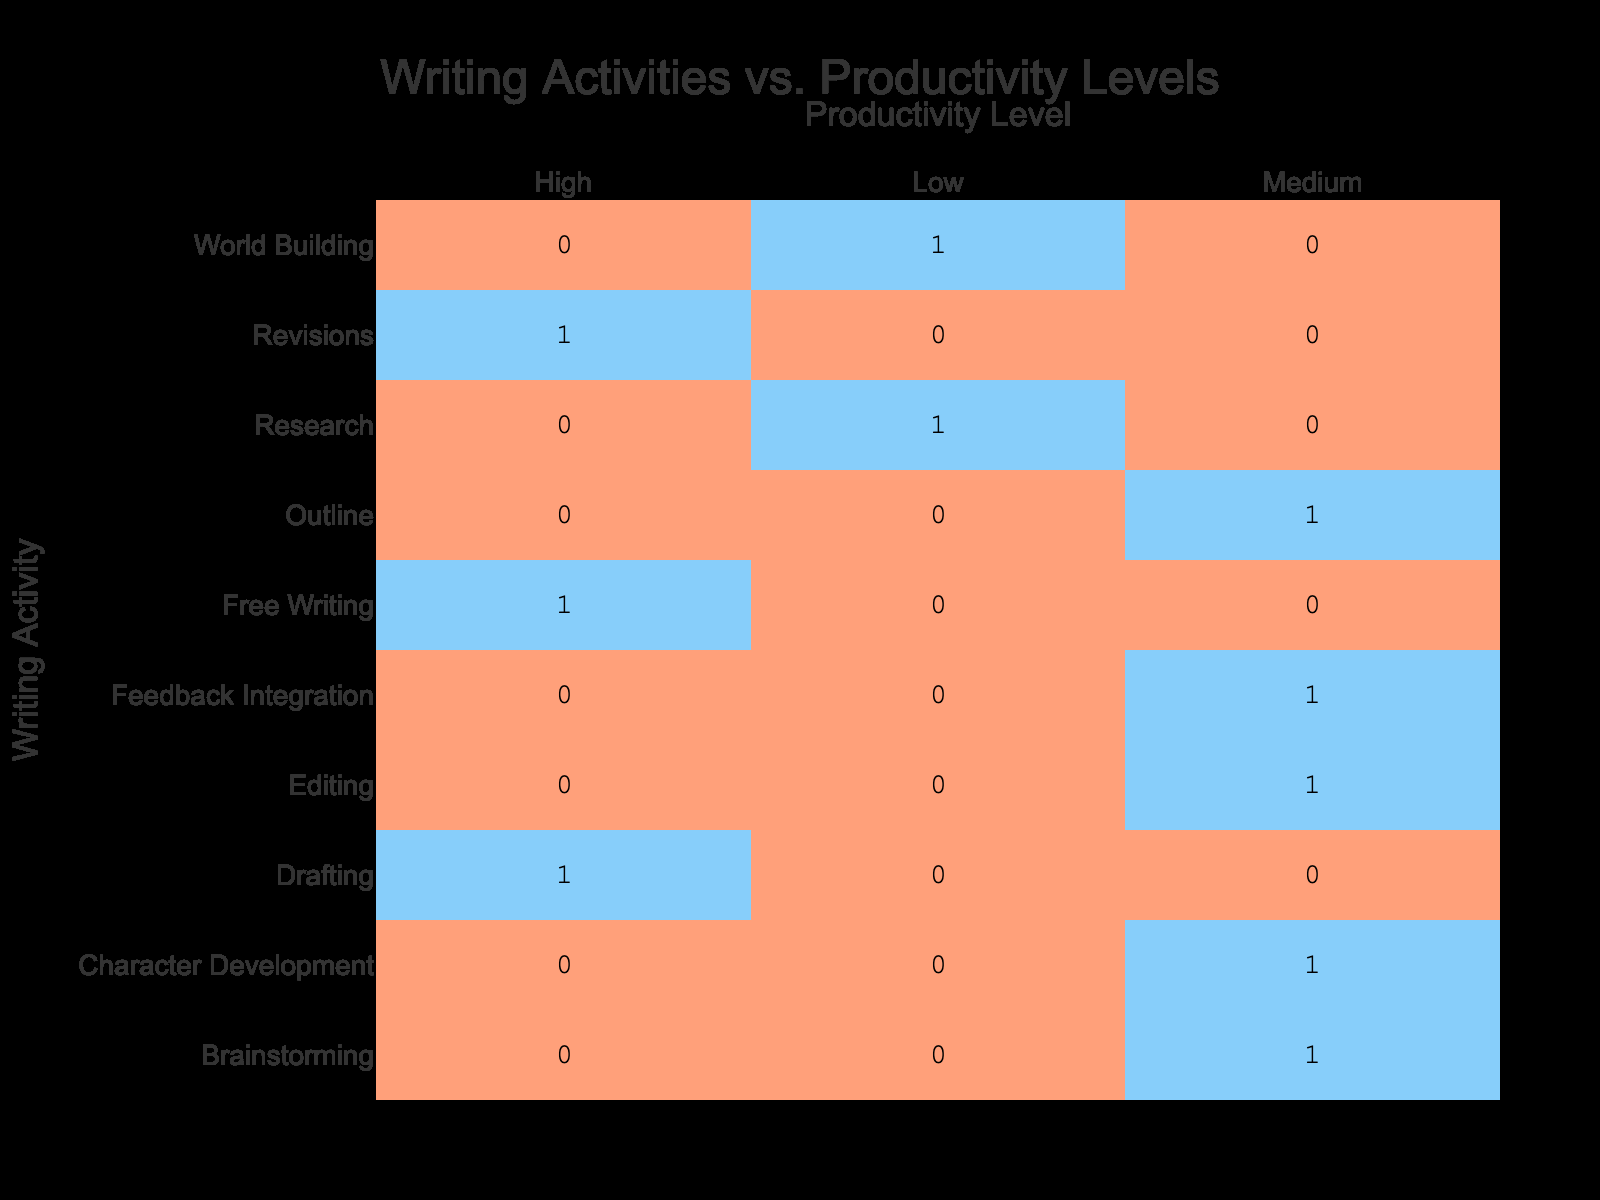What is the productivity level associated with the "Drafting" activity? The "Drafting" activity has a productivity level of "High", which can be seen directly in the table under the corresponding row.
Answer: High How many writing activities have a "Medium" productivity level? By counting the entries under the "Medium" category in the table, we find that there are four activities: Outline, Editing, Brainstorming, and Character Development.
Answer: 4 What writing activity has the lowest productivity level, and what is it? The writing activity with the lowest productivity level is "Research" which is categorized as "Low". This can be determined from the row for Research in the table where the productivity level is noted.
Answer: Research, Low Which writing activity has the highest time spent among those with a "High" productivity level? The highest time spent among activities with a "High" productivity level is "Drafting" with 5 hours. This can be identified by looking at the "High" category and comparing the time spent for each activity.
Answer: Drafting, 5 hours Is there any writing activity that has a "Low" productivity level with more than 3 hours spent? Yes, "World Building" has a "Low" productivity level and 3 hours spent. The data from the table supports this since it lists World Building under low productivity and shows the corresponding time.
Answer: Yes What is the total time spent on writing activities categorized as having "High" productivity levels? The activities with "High" productivity levels are Drafting (5), Revisions (4), and Free Writing (2). Adding these, the total time comes to 5 + 4 + 2 = 11 hours.
Answer: 11 hours How many activities were categorized as "High" productivity level and had time spent of 4 hours or less? The activities categorized as "High" productivity and had time spent of 4 hours or less are Free Writing (2 hours) and Revisions (4 hours), resulting in 2 activities when counted together.
Answer: 2 What percentage of all activities are associated with "Medium" productivity levels? There are 10 total activities, and 4 of them are categorized as "Medium". To find the percentage, we use the formula: (4/10)*100 = 40%.
Answer: 40% 